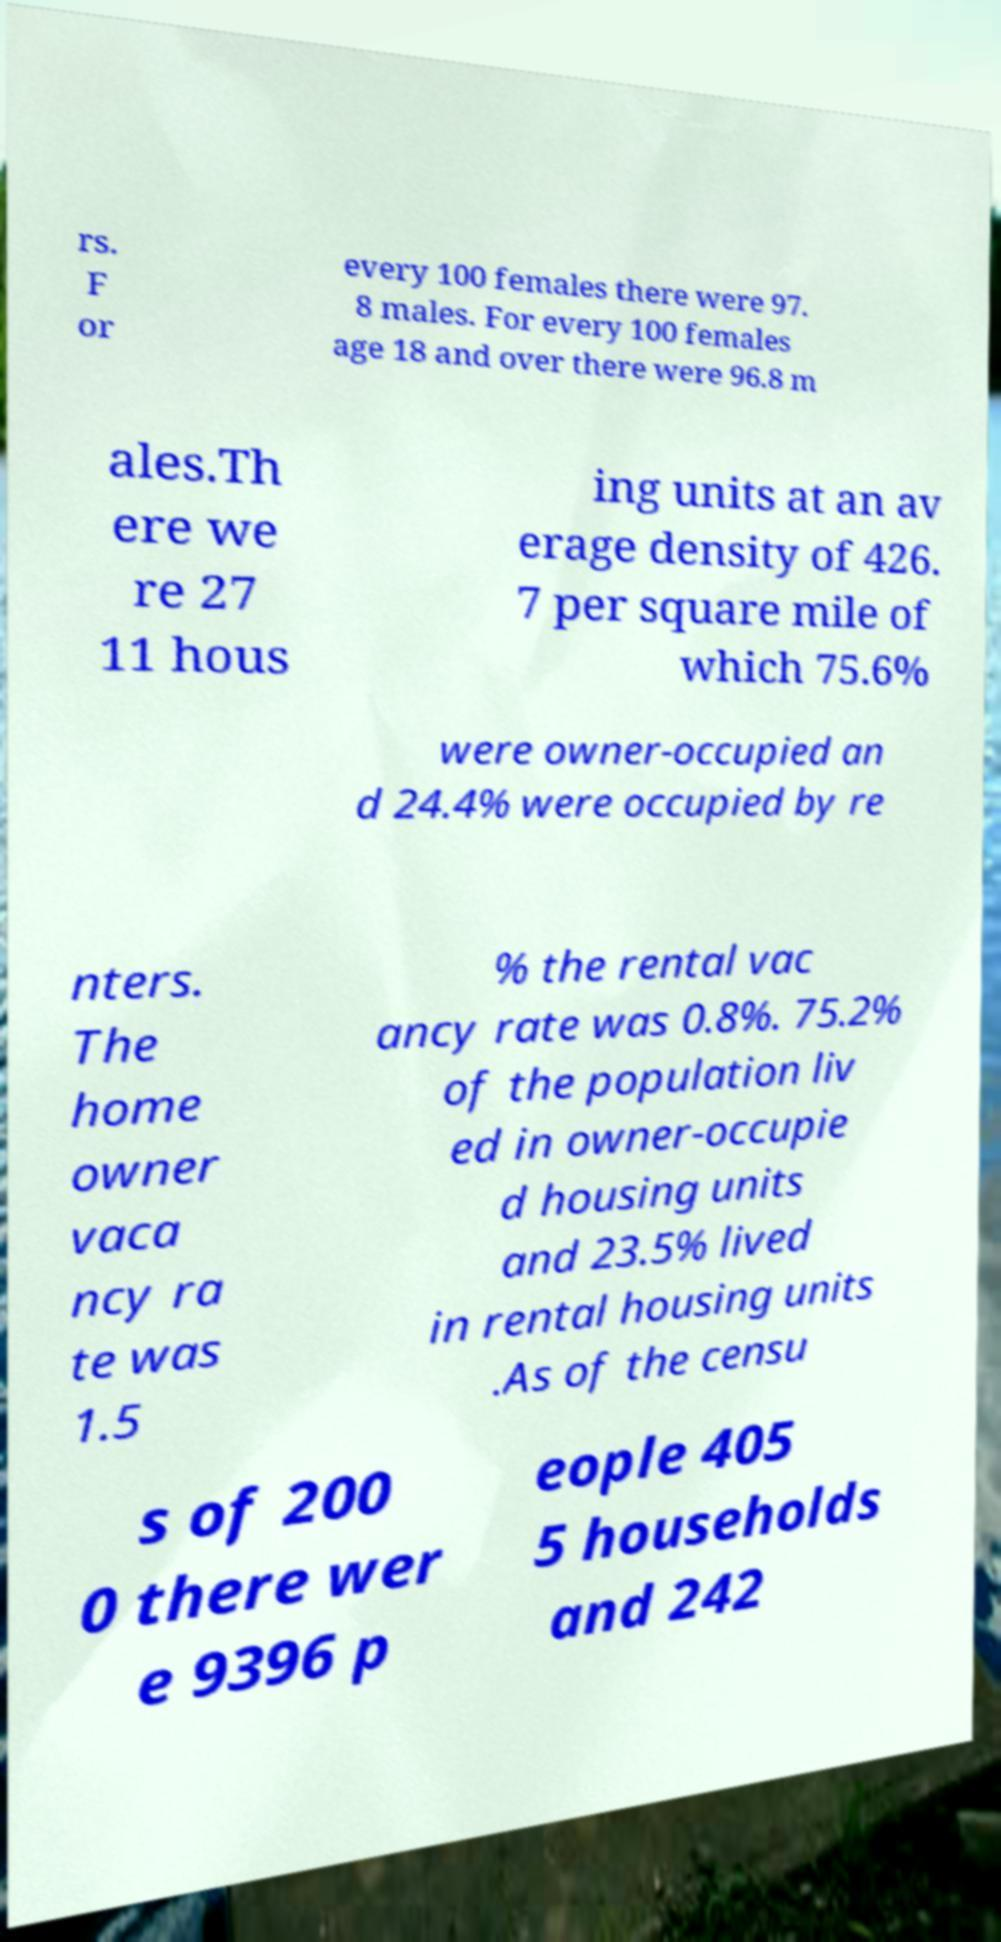Please read and relay the text visible in this image. What does it say? rs. F or every 100 females there were 97. 8 males. For every 100 females age 18 and over there were 96.8 m ales.Th ere we re 27 11 hous ing units at an av erage density of 426. 7 per square mile of which 75.6% were owner-occupied an d 24.4% were occupied by re nters. The home owner vaca ncy ra te was 1.5 % the rental vac ancy rate was 0.8%. 75.2% of the population liv ed in owner-occupie d housing units and 23.5% lived in rental housing units .As of the censu s of 200 0 there wer e 9396 p eople 405 5 households and 242 